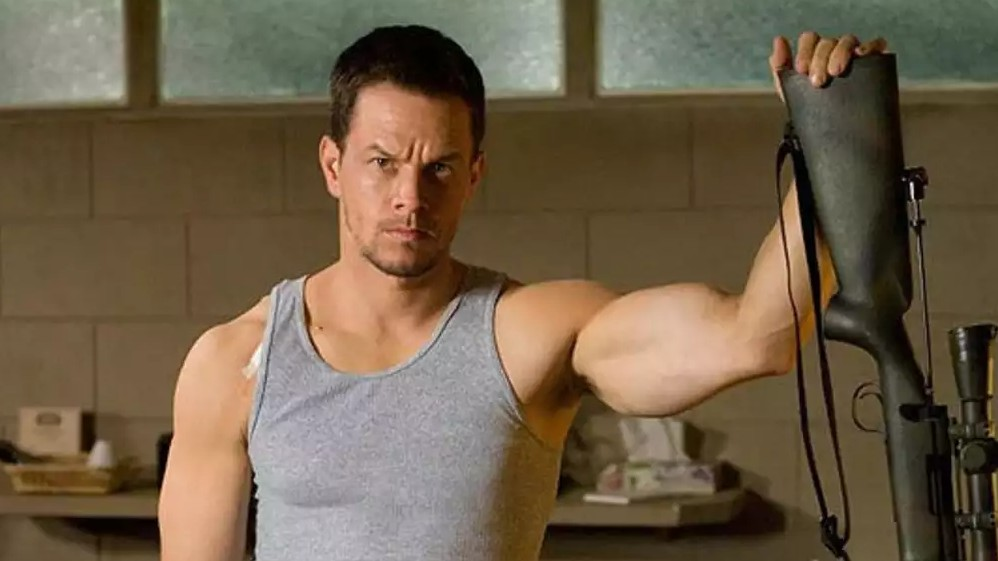What might be the actor thinking about in this moment? Given his serious expression and the tense atmosphere, it's possible the actor is deep in thought, perhaps strategizing his next move or considering the ramifications of a recent event. The intensity in his gaze suggests he is focused on something important, possibly reflecting on a mission or a crisis he must address. 